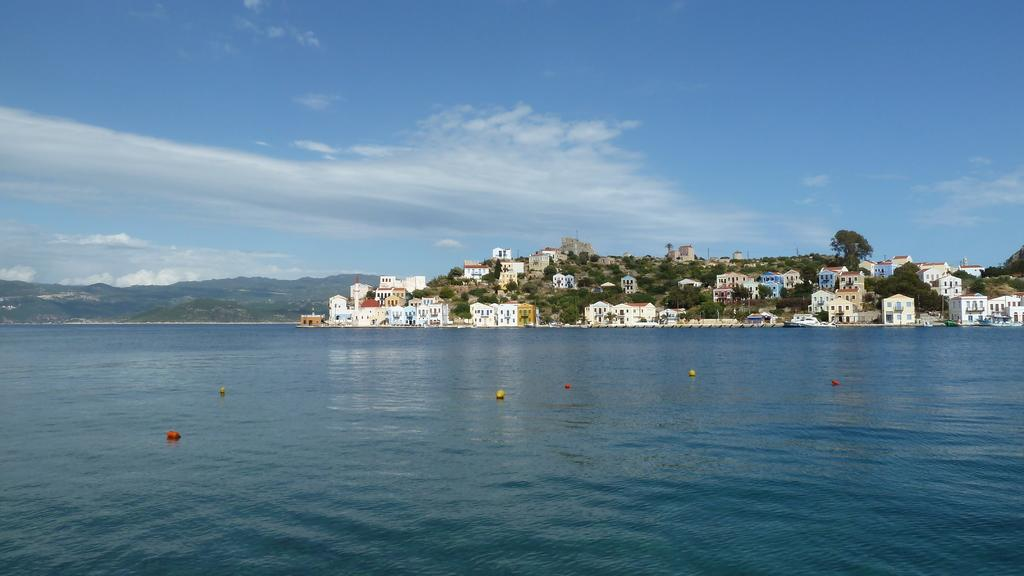What type of structures can be seen in the image? There are buildings in the image. What natural elements are present in the image? There are trees and hills visible in the image. What can be seen in the water in the image? The image does not provide a clear view of the water, so it is not possible to determine what is in the water. What else is present in the image besides buildings, trees, and hills? There are objects in the image. What is visible in the sky in the image? The sky is visible in the image, and there are clouds present. What type of grain is being harvested in the image? There is no grain present in the image; it features buildings, trees, hills, water, and clouds. How many potatoes can be seen in the image? There are no potatoes present in the image. 